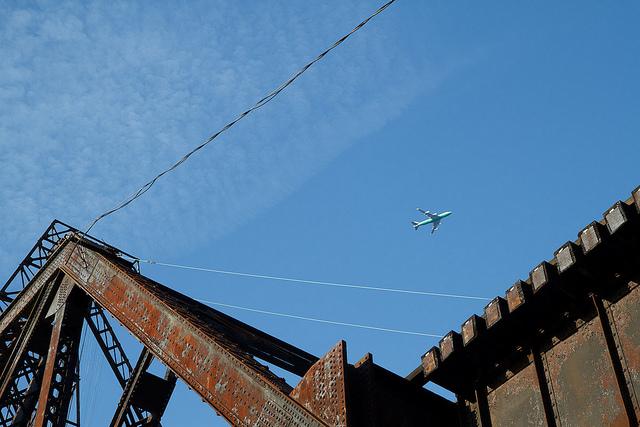Is the bridge new or old?
Be succinct. Old. Is it raining?
Concise answer only. No. What is flying through the air?
Short answer required. Airplane. Is this airplane putting on a show?
Concise answer only. No. 